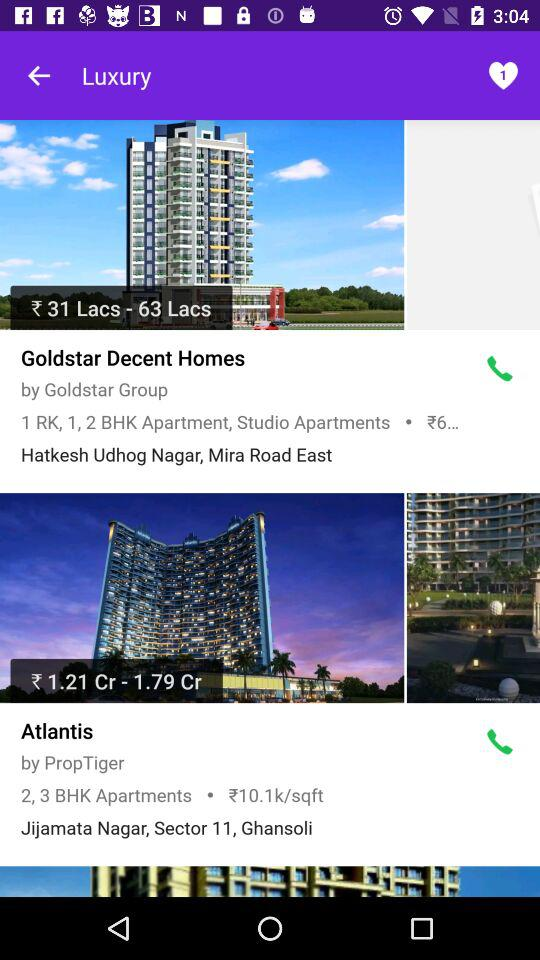Which property has a higher price range, Goldstar Decent Homes or Atlantis?
Answer the question using a single word or phrase. Atlantis 